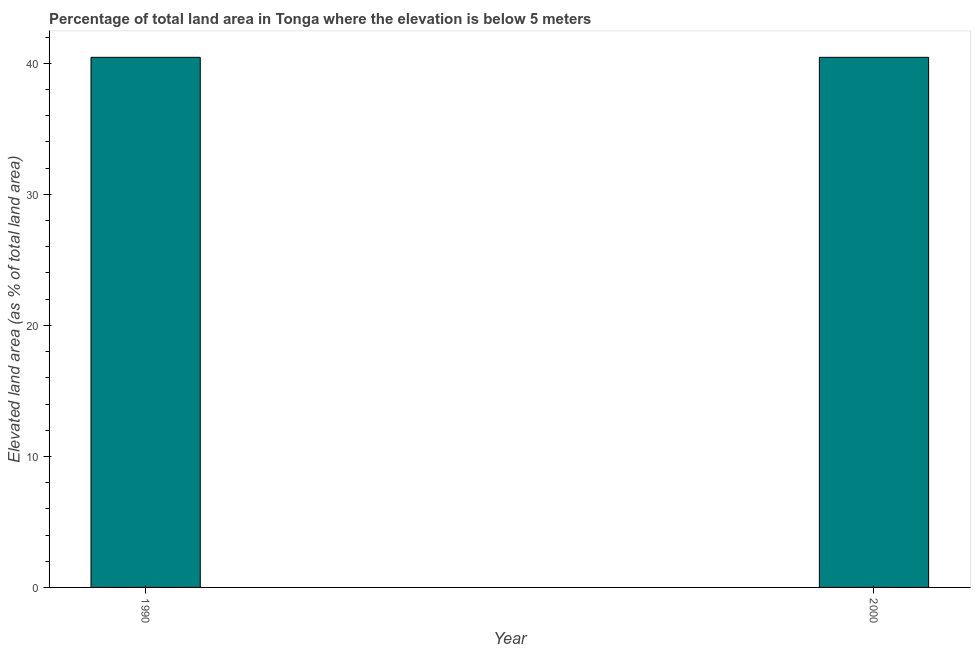What is the title of the graph?
Keep it short and to the point. Percentage of total land area in Tonga where the elevation is below 5 meters. What is the label or title of the Y-axis?
Keep it short and to the point. Elevated land area (as % of total land area). What is the total elevated land area in 1990?
Your answer should be compact. 40.46. Across all years, what is the maximum total elevated land area?
Ensure brevity in your answer.  40.46. Across all years, what is the minimum total elevated land area?
Offer a terse response. 40.46. In which year was the total elevated land area maximum?
Offer a terse response. 1990. In which year was the total elevated land area minimum?
Provide a succinct answer. 1990. What is the sum of the total elevated land area?
Provide a succinct answer. 80.92. What is the difference between the total elevated land area in 1990 and 2000?
Provide a succinct answer. 0. What is the average total elevated land area per year?
Keep it short and to the point. 40.46. What is the median total elevated land area?
Offer a terse response. 40.46. In how many years, is the total elevated land area greater than 32 %?
Your response must be concise. 2. In how many years, is the total elevated land area greater than the average total elevated land area taken over all years?
Offer a very short reply. 0. Are all the bars in the graph horizontal?
Provide a short and direct response. No. How many years are there in the graph?
Your response must be concise. 2. Are the values on the major ticks of Y-axis written in scientific E-notation?
Provide a short and direct response. No. What is the Elevated land area (as % of total land area) of 1990?
Ensure brevity in your answer.  40.46. What is the Elevated land area (as % of total land area) in 2000?
Your answer should be compact. 40.46. What is the difference between the Elevated land area (as % of total land area) in 1990 and 2000?
Ensure brevity in your answer.  0. What is the ratio of the Elevated land area (as % of total land area) in 1990 to that in 2000?
Make the answer very short. 1. 